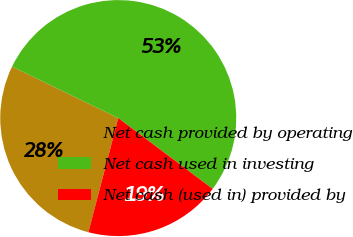Convert chart to OTSL. <chart><loc_0><loc_0><loc_500><loc_500><pie_chart><fcel>Net cash provided by operating<fcel>Net cash used in investing<fcel>Net cash (used in) provided by<nl><fcel>28.12%<fcel>53.06%<fcel>18.83%<nl></chart> 